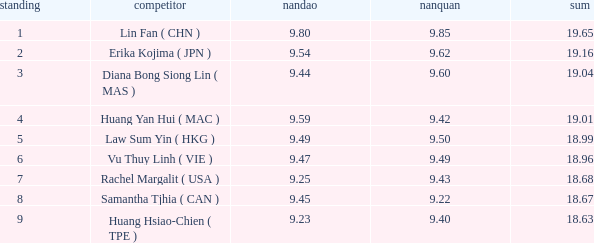Which Nanquan has a Nandao smaller than 9.44, and a Rank smaller than 9, and a Total larger than 18.68? None. 